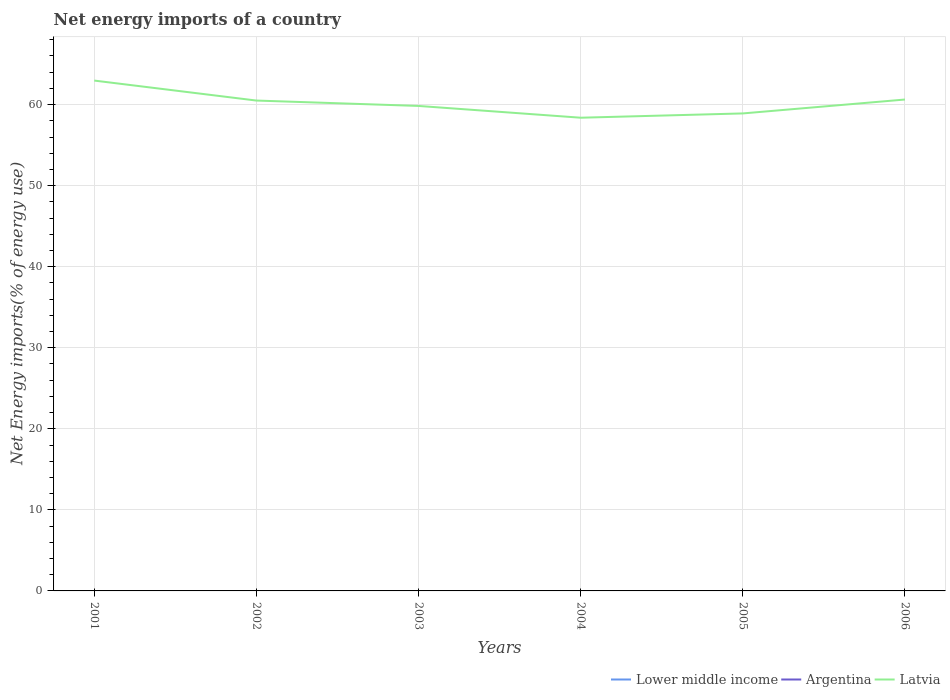How many different coloured lines are there?
Offer a terse response. 1. Does the line corresponding to Argentina intersect with the line corresponding to Latvia?
Provide a short and direct response. No. Across all years, what is the maximum net energy imports in Latvia?
Your answer should be compact. 58.38. What is the total net energy imports in Latvia in the graph?
Offer a terse response. 3.13. What is the difference between the highest and the second highest net energy imports in Latvia?
Make the answer very short. 4.58. How many lines are there?
Your response must be concise. 1. Are the values on the major ticks of Y-axis written in scientific E-notation?
Ensure brevity in your answer.  No. Does the graph contain any zero values?
Offer a very short reply. Yes. What is the title of the graph?
Give a very brief answer. Net energy imports of a country. Does "Turkmenistan" appear as one of the legend labels in the graph?
Your response must be concise. No. What is the label or title of the Y-axis?
Offer a terse response. Net Energy imports(% of energy use). What is the Net Energy imports(% of energy use) in Lower middle income in 2001?
Provide a succinct answer. 0. What is the Net Energy imports(% of energy use) in Latvia in 2001?
Your answer should be very brief. 62.96. What is the Net Energy imports(% of energy use) of Lower middle income in 2002?
Ensure brevity in your answer.  0. What is the Net Energy imports(% of energy use) in Latvia in 2002?
Offer a very short reply. 60.5. What is the Net Energy imports(% of energy use) of Argentina in 2003?
Your answer should be compact. 0. What is the Net Energy imports(% of energy use) of Latvia in 2003?
Make the answer very short. 59.83. What is the Net Energy imports(% of energy use) of Latvia in 2004?
Your answer should be very brief. 58.38. What is the Net Energy imports(% of energy use) of Lower middle income in 2005?
Make the answer very short. 0. What is the Net Energy imports(% of energy use) of Latvia in 2005?
Your answer should be very brief. 58.91. What is the Net Energy imports(% of energy use) in Argentina in 2006?
Make the answer very short. 0. What is the Net Energy imports(% of energy use) in Latvia in 2006?
Provide a succinct answer. 60.62. Across all years, what is the maximum Net Energy imports(% of energy use) of Latvia?
Ensure brevity in your answer.  62.96. Across all years, what is the minimum Net Energy imports(% of energy use) of Latvia?
Keep it short and to the point. 58.38. What is the total Net Energy imports(% of energy use) of Argentina in the graph?
Provide a short and direct response. 0. What is the total Net Energy imports(% of energy use) in Latvia in the graph?
Make the answer very short. 361.2. What is the difference between the Net Energy imports(% of energy use) in Latvia in 2001 and that in 2002?
Your answer should be compact. 2.47. What is the difference between the Net Energy imports(% of energy use) in Latvia in 2001 and that in 2003?
Offer a very short reply. 3.13. What is the difference between the Net Energy imports(% of energy use) in Latvia in 2001 and that in 2004?
Offer a very short reply. 4.58. What is the difference between the Net Energy imports(% of energy use) of Latvia in 2001 and that in 2005?
Keep it short and to the point. 4.05. What is the difference between the Net Energy imports(% of energy use) in Latvia in 2001 and that in 2006?
Offer a very short reply. 2.34. What is the difference between the Net Energy imports(% of energy use) of Latvia in 2002 and that in 2003?
Your answer should be very brief. 0.66. What is the difference between the Net Energy imports(% of energy use) in Latvia in 2002 and that in 2004?
Make the answer very short. 2.12. What is the difference between the Net Energy imports(% of energy use) in Latvia in 2002 and that in 2005?
Give a very brief answer. 1.59. What is the difference between the Net Energy imports(% of energy use) in Latvia in 2002 and that in 2006?
Ensure brevity in your answer.  -0.13. What is the difference between the Net Energy imports(% of energy use) in Latvia in 2003 and that in 2004?
Offer a very short reply. 1.45. What is the difference between the Net Energy imports(% of energy use) of Latvia in 2003 and that in 2005?
Your response must be concise. 0.92. What is the difference between the Net Energy imports(% of energy use) in Latvia in 2003 and that in 2006?
Provide a succinct answer. -0.79. What is the difference between the Net Energy imports(% of energy use) in Latvia in 2004 and that in 2005?
Give a very brief answer. -0.53. What is the difference between the Net Energy imports(% of energy use) of Latvia in 2004 and that in 2006?
Your answer should be very brief. -2.24. What is the difference between the Net Energy imports(% of energy use) in Latvia in 2005 and that in 2006?
Your response must be concise. -1.72. What is the average Net Energy imports(% of energy use) in Lower middle income per year?
Your answer should be compact. 0. What is the average Net Energy imports(% of energy use) in Argentina per year?
Keep it short and to the point. 0. What is the average Net Energy imports(% of energy use) in Latvia per year?
Keep it short and to the point. 60.2. What is the ratio of the Net Energy imports(% of energy use) of Latvia in 2001 to that in 2002?
Your response must be concise. 1.04. What is the ratio of the Net Energy imports(% of energy use) of Latvia in 2001 to that in 2003?
Your answer should be very brief. 1.05. What is the ratio of the Net Energy imports(% of energy use) of Latvia in 2001 to that in 2004?
Offer a very short reply. 1.08. What is the ratio of the Net Energy imports(% of energy use) of Latvia in 2001 to that in 2005?
Give a very brief answer. 1.07. What is the ratio of the Net Energy imports(% of energy use) of Latvia in 2001 to that in 2006?
Provide a succinct answer. 1.04. What is the ratio of the Net Energy imports(% of energy use) in Latvia in 2002 to that in 2003?
Ensure brevity in your answer.  1.01. What is the ratio of the Net Energy imports(% of energy use) of Latvia in 2002 to that in 2004?
Provide a succinct answer. 1.04. What is the ratio of the Net Energy imports(% of energy use) of Latvia in 2002 to that in 2005?
Make the answer very short. 1.03. What is the ratio of the Net Energy imports(% of energy use) in Latvia in 2003 to that in 2004?
Provide a succinct answer. 1.02. What is the ratio of the Net Energy imports(% of energy use) in Latvia in 2003 to that in 2005?
Provide a short and direct response. 1.02. What is the ratio of the Net Energy imports(% of energy use) of Latvia in 2003 to that in 2006?
Provide a short and direct response. 0.99. What is the ratio of the Net Energy imports(% of energy use) of Latvia in 2004 to that in 2005?
Ensure brevity in your answer.  0.99. What is the ratio of the Net Energy imports(% of energy use) of Latvia in 2004 to that in 2006?
Ensure brevity in your answer.  0.96. What is the ratio of the Net Energy imports(% of energy use) in Latvia in 2005 to that in 2006?
Your answer should be very brief. 0.97. What is the difference between the highest and the second highest Net Energy imports(% of energy use) of Latvia?
Ensure brevity in your answer.  2.34. What is the difference between the highest and the lowest Net Energy imports(% of energy use) in Latvia?
Your answer should be compact. 4.58. 